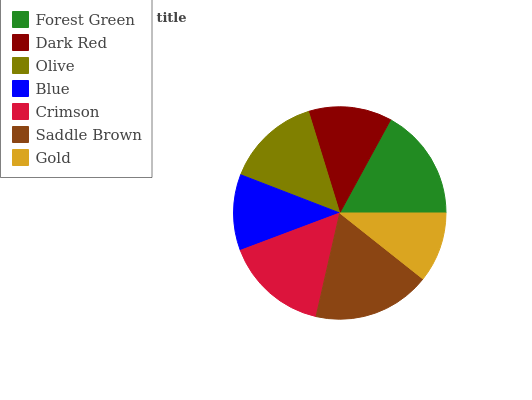Is Gold the minimum?
Answer yes or no. Yes. Is Saddle Brown the maximum?
Answer yes or no. Yes. Is Dark Red the minimum?
Answer yes or no. No. Is Dark Red the maximum?
Answer yes or no. No. Is Forest Green greater than Dark Red?
Answer yes or no. Yes. Is Dark Red less than Forest Green?
Answer yes or no. Yes. Is Dark Red greater than Forest Green?
Answer yes or no. No. Is Forest Green less than Dark Red?
Answer yes or no. No. Is Olive the high median?
Answer yes or no. Yes. Is Olive the low median?
Answer yes or no. Yes. Is Gold the high median?
Answer yes or no. No. Is Dark Red the low median?
Answer yes or no. No. 